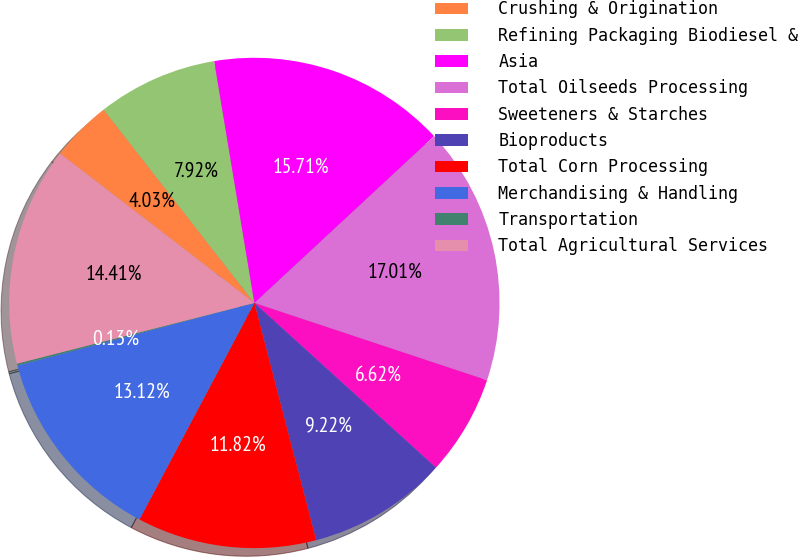Convert chart to OTSL. <chart><loc_0><loc_0><loc_500><loc_500><pie_chart><fcel>Crushing & Origination<fcel>Refining Packaging Biodiesel &<fcel>Asia<fcel>Total Oilseeds Processing<fcel>Sweeteners & Starches<fcel>Bioproducts<fcel>Total Corn Processing<fcel>Merchandising & Handling<fcel>Transportation<fcel>Total Agricultural Services<nl><fcel>4.03%<fcel>7.92%<fcel>15.71%<fcel>17.01%<fcel>6.62%<fcel>9.22%<fcel>11.82%<fcel>13.12%<fcel>0.13%<fcel>14.41%<nl></chart> 